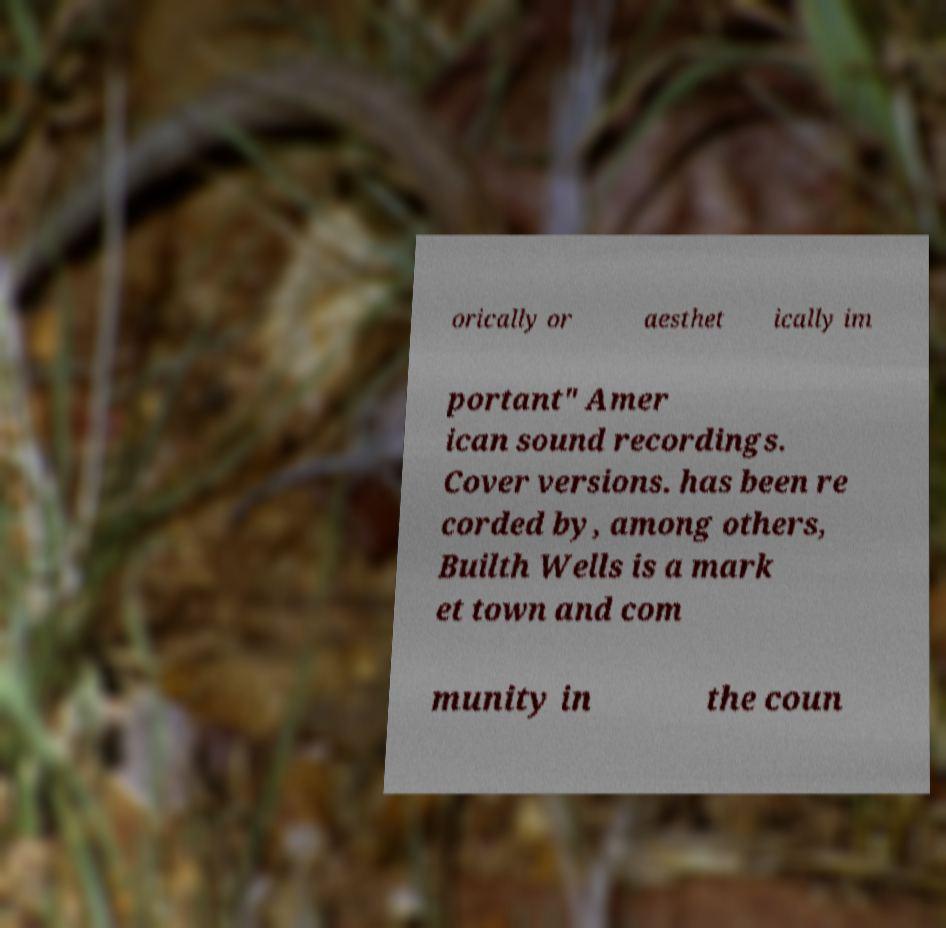Please read and relay the text visible in this image. What does it say? orically or aesthet ically im portant" Amer ican sound recordings. Cover versions. has been re corded by, among others, Builth Wells is a mark et town and com munity in the coun 